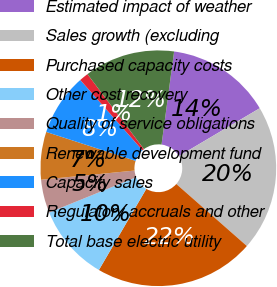<chart> <loc_0><loc_0><loc_500><loc_500><pie_chart><fcel>Estimated impact of weather<fcel>Sales growth (excluding<fcel>Purchased capacity costs<fcel>Other cost recovery<fcel>Quality of service obligations<fcel>Renewable development fund<fcel>Capacity sales<fcel>Regulatory accruals and other<fcel>Total base electric utility<nl><fcel>14.36%<fcel>19.98%<fcel>21.94%<fcel>10.45%<fcel>4.58%<fcel>6.54%<fcel>8.49%<fcel>1.25%<fcel>12.41%<nl></chart> 